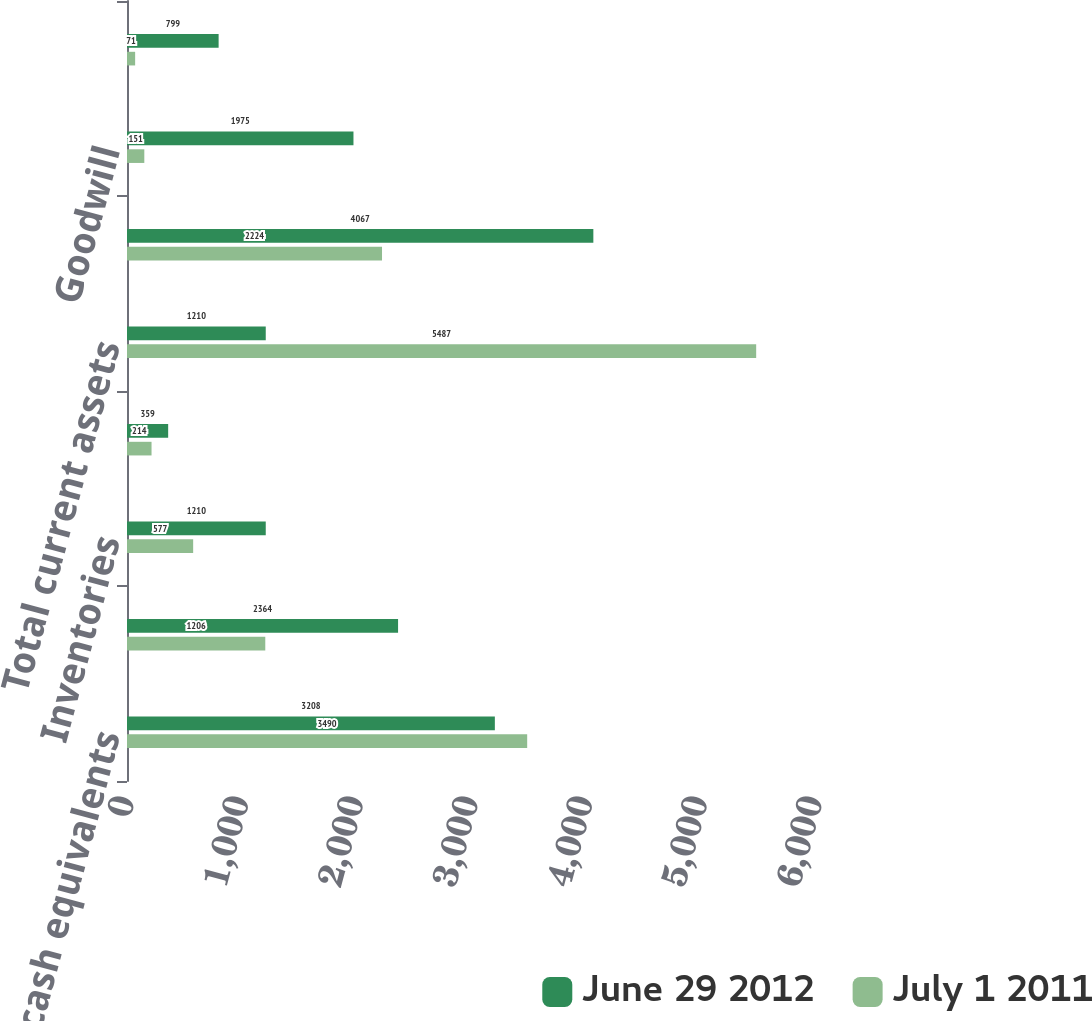Convert chart. <chart><loc_0><loc_0><loc_500><loc_500><stacked_bar_chart><ecel><fcel>Cash and cash equivalents<fcel>Accounts receivable net<fcel>Inventories<fcel>Other current assets<fcel>Total current assets<fcel>Property plant and equipment<fcel>Goodwill<fcel>Other intangible assets net<nl><fcel>June 29 2012<fcel>3208<fcel>2364<fcel>1210<fcel>359<fcel>1210<fcel>4067<fcel>1975<fcel>799<nl><fcel>July 1 2011<fcel>3490<fcel>1206<fcel>577<fcel>214<fcel>5487<fcel>2224<fcel>151<fcel>71<nl></chart> 